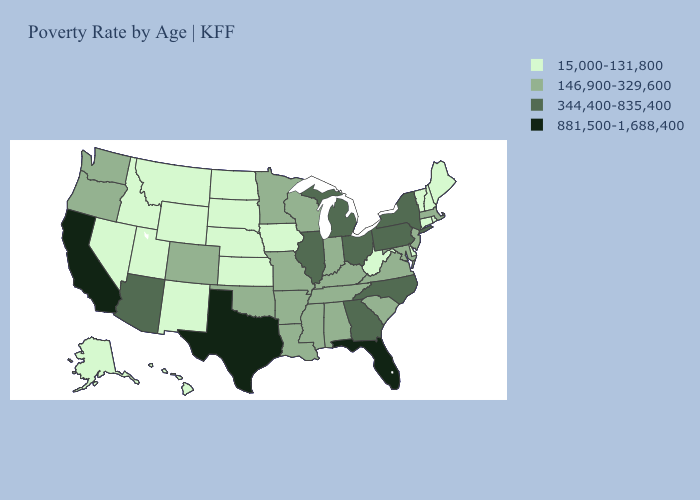What is the value of Alabama?
Keep it brief. 146,900-329,600. What is the lowest value in the USA?
Short answer required. 15,000-131,800. Among the states that border Utah , does Colorado have the highest value?
Keep it brief. No. What is the lowest value in the South?
Quick response, please. 15,000-131,800. Name the states that have a value in the range 15,000-131,800?
Answer briefly. Alaska, Connecticut, Delaware, Hawaii, Idaho, Iowa, Kansas, Maine, Montana, Nebraska, Nevada, New Hampshire, New Mexico, North Dakota, Rhode Island, South Dakota, Utah, Vermont, West Virginia, Wyoming. What is the value of Washington?
Answer briefly. 146,900-329,600. What is the lowest value in states that border Oregon?
Give a very brief answer. 15,000-131,800. What is the value of New Mexico?
Concise answer only. 15,000-131,800. Does Texas have the lowest value in the USA?
Be succinct. No. Name the states that have a value in the range 15,000-131,800?
Short answer required. Alaska, Connecticut, Delaware, Hawaii, Idaho, Iowa, Kansas, Maine, Montana, Nebraska, Nevada, New Hampshire, New Mexico, North Dakota, Rhode Island, South Dakota, Utah, Vermont, West Virginia, Wyoming. Among the states that border Missouri , which have the highest value?
Quick response, please. Illinois. Which states have the lowest value in the MidWest?
Short answer required. Iowa, Kansas, Nebraska, North Dakota, South Dakota. Which states hav the highest value in the West?
Give a very brief answer. California. Does the map have missing data?
Answer briefly. No. Does Massachusetts have a lower value than Colorado?
Give a very brief answer. No. 